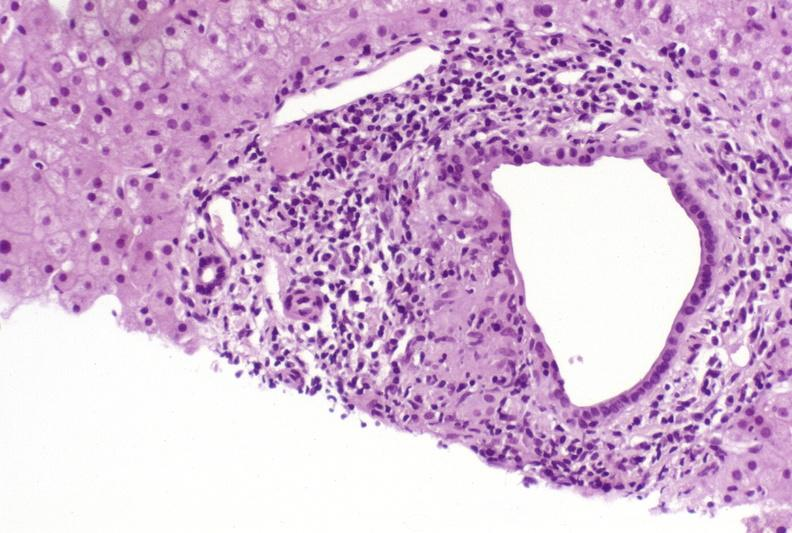what is present?
Answer the question using a single word or phrase. Hepatobiliary 